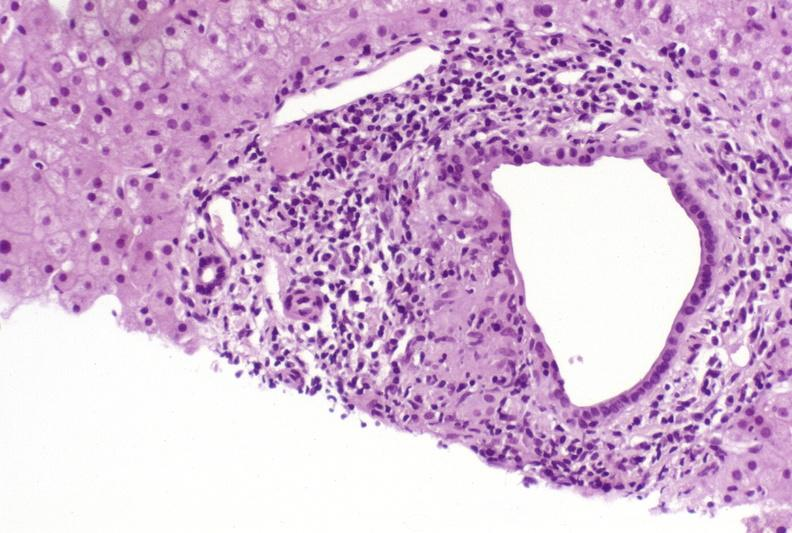what is present?
Answer the question using a single word or phrase. Hepatobiliary 